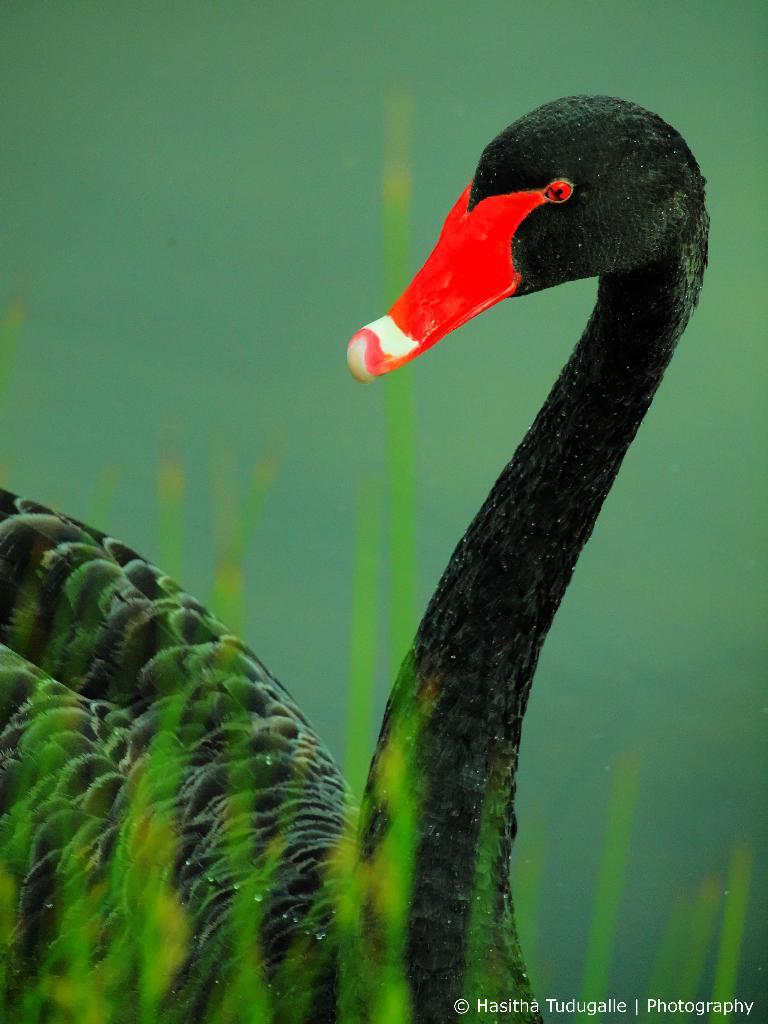What is depicted in the painting in the image? There is a painting of a bird in the image. What type of jam is being used to create the bird's reaction in the painting? There is no jam or reaction present in the painting; it is a painting of a bird. Can you hear the bird whistling in the painting? The painting is a visual representation and does not include audible elements like whistling. 